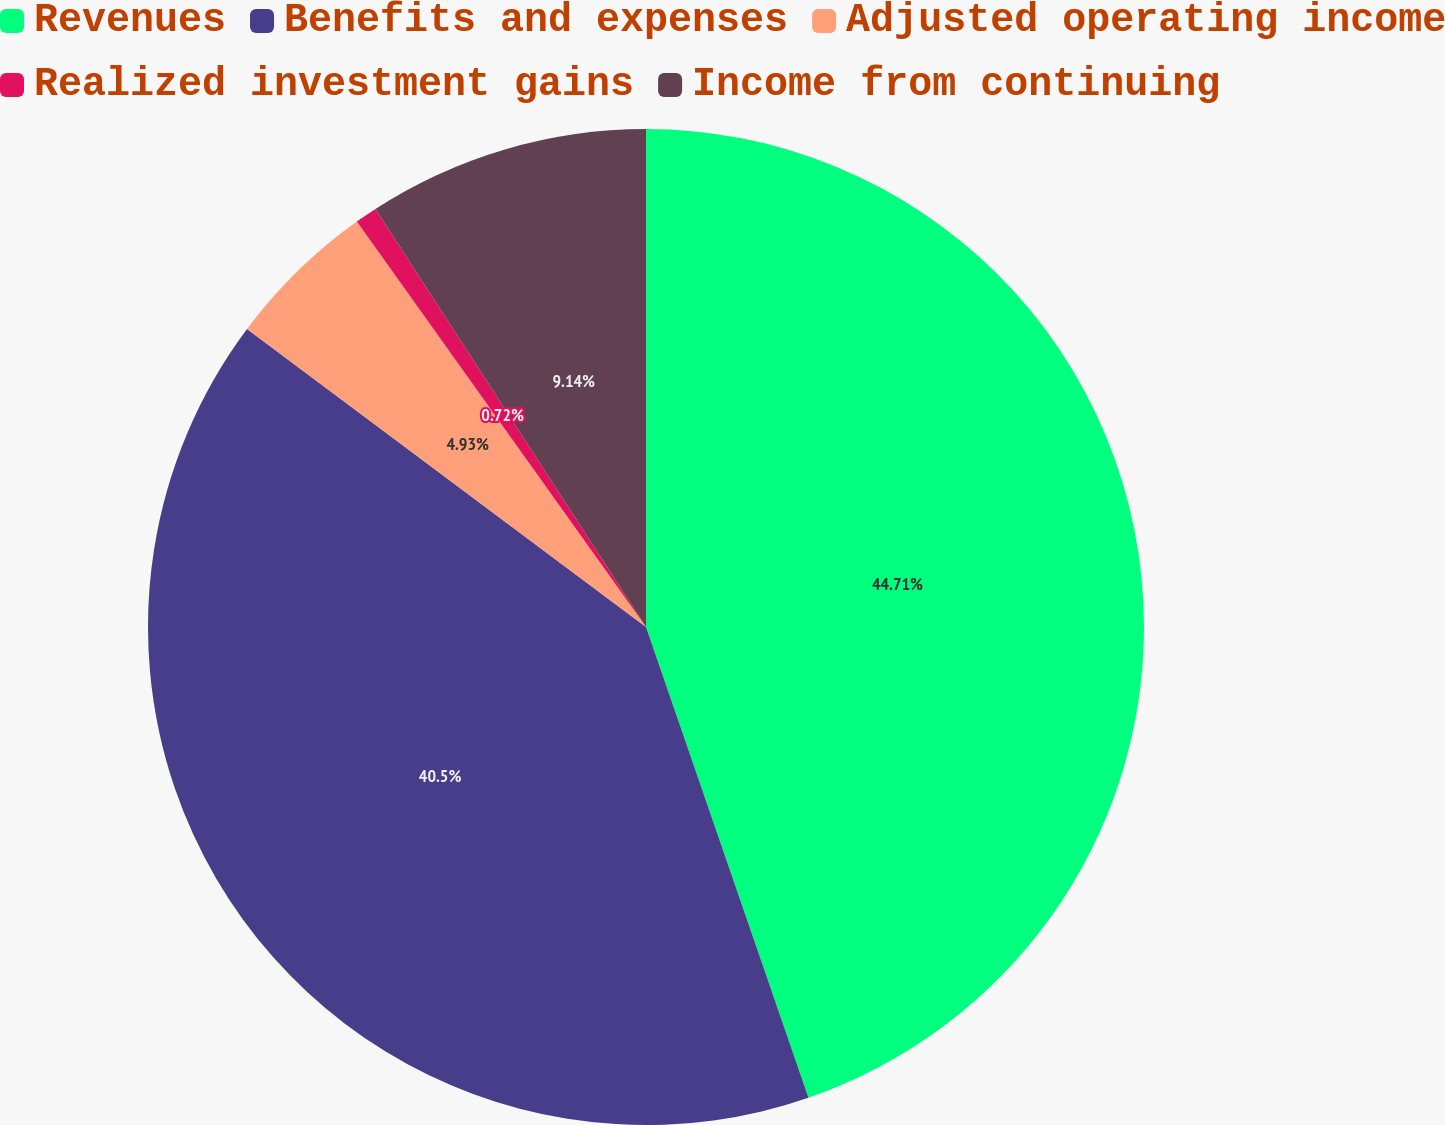Convert chart. <chart><loc_0><loc_0><loc_500><loc_500><pie_chart><fcel>Revenues<fcel>Benefits and expenses<fcel>Adjusted operating income<fcel>Realized investment gains<fcel>Income from continuing<nl><fcel>44.71%<fcel>40.5%<fcel>4.93%<fcel>0.72%<fcel>9.14%<nl></chart> 